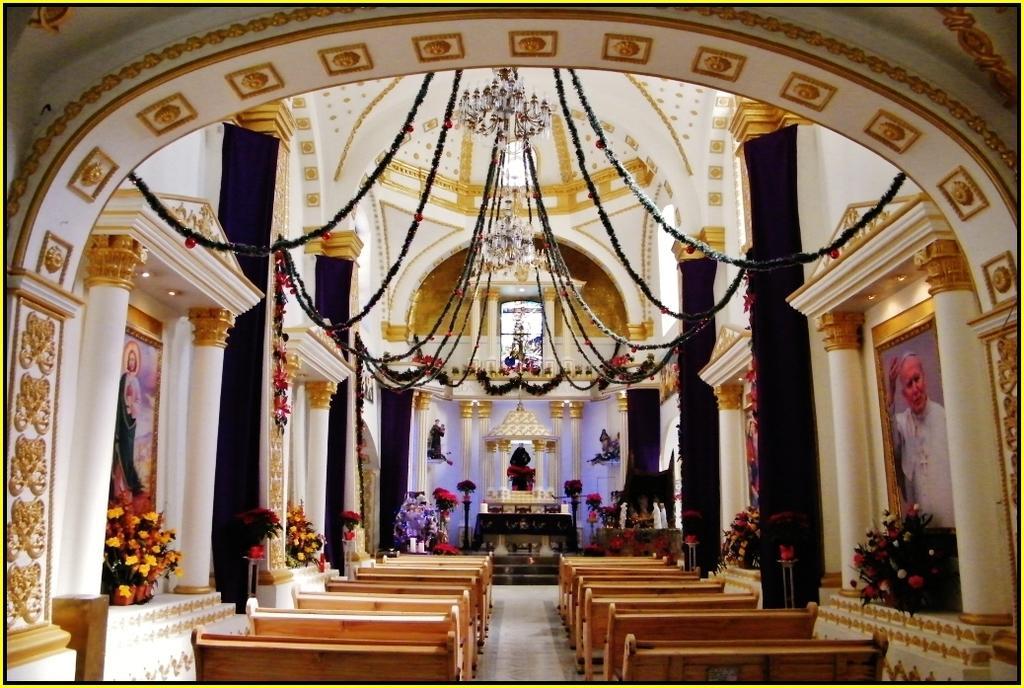Please provide a concise description of this image. Here we can see benches on the floor,flower vases on a platform on the left and right side and we can see pillars,designs and frames on the wall and decorative items at the top. 